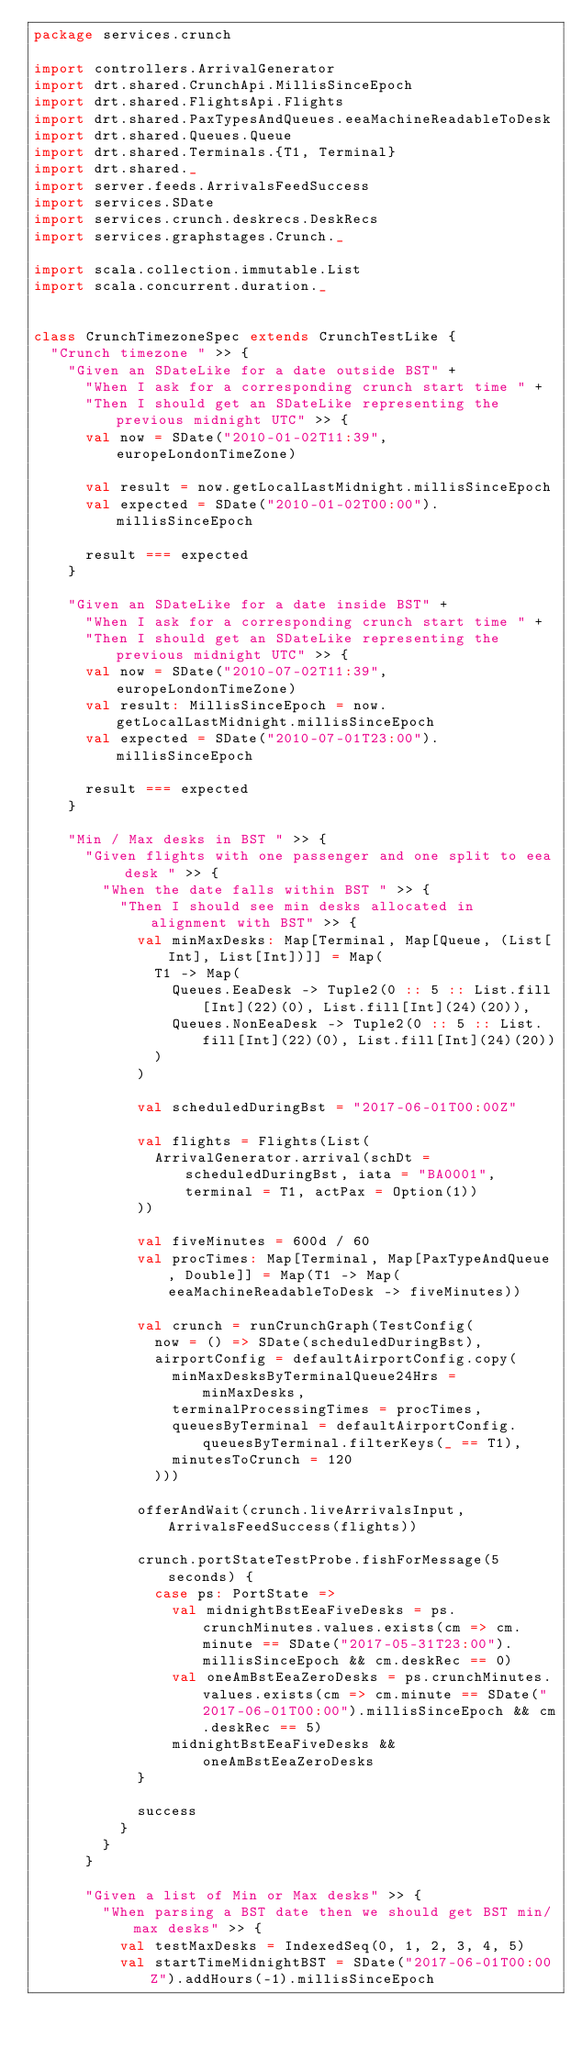Convert code to text. <code><loc_0><loc_0><loc_500><loc_500><_Scala_>package services.crunch

import controllers.ArrivalGenerator
import drt.shared.CrunchApi.MillisSinceEpoch
import drt.shared.FlightsApi.Flights
import drt.shared.PaxTypesAndQueues.eeaMachineReadableToDesk
import drt.shared.Queues.Queue
import drt.shared.Terminals.{T1, Terminal}
import drt.shared._
import server.feeds.ArrivalsFeedSuccess
import services.SDate
import services.crunch.deskrecs.DeskRecs
import services.graphstages.Crunch._

import scala.collection.immutable.List
import scala.concurrent.duration._


class CrunchTimezoneSpec extends CrunchTestLike {
  "Crunch timezone " >> {
    "Given an SDateLike for a date outside BST" +
      "When I ask for a corresponding crunch start time " +
      "Then I should get an SDateLike representing the previous midnight UTC" >> {
      val now = SDate("2010-01-02T11:39", europeLondonTimeZone)

      val result = now.getLocalLastMidnight.millisSinceEpoch
      val expected = SDate("2010-01-02T00:00").millisSinceEpoch

      result === expected
    }

    "Given an SDateLike for a date inside BST" +
      "When I ask for a corresponding crunch start time " +
      "Then I should get an SDateLike representing the previous midnight UTC" >> {
      val now = SDate("2010-07-02T11:39", europeLondonTimeZone)
      val result: MillisSinceEpoch = now.getLocalLastMidnight.millisSinceEpoch
      val expected = SDate("2010-07-01T23:00").millisSinceEpoch

      result === expected
    }

    "Min / Max desks in BST " >> {
      "Given flights with one passenger and one split to eea desk " >> {
        "When the date falls within BST " >> {
          "Then I should see min desks allocated in alignment with BST" >> {
            val minMaxDesks: Map[Terminal, Map[Queue, (List[Int], List[Int])]] = Map(
              T1 -> Map(
                Queues.EeaDesk -> Tuple2(0 :: 5 :: List.fill[Int](22)(0), List.fill[Int](24)(20)),
                Queues.NonEeaDesk -> Tuple2(0 :: 5 :: List.fill[Int](22)(0), List.fill[Int](24)(20))
              )
            )

            val scheduledDuringBst = "2017-06-01T00:00Z"

            val flights = Flights(List(
              ArrivalGenerator.arrival(schDt = scheduledDuringBst, iata = "BA0001", terminal = T1, actPax = Option(1))
            ))

            val fiveMinutes = 600d / 60
            val procTimes: Map[Terminal, Map[PaxTypeAndQueue, Double]] = Map(T1 -> Map(eeaMachineReadableToDesk -> fiveMinutes))

            val crunch = runCrunchGraph(TestConfig(
              now = () => SDate(scheduledDuringBst),
              airportConfig = defaultAirportConfig.copy(
                minMaxDesksByTerminalQueue24Hrs = minMaxDesks,
                terminalProcessingTimes = procTimes,
                queuesByTerminal = defaultAirportConfig.queuesByTerminal.filterKeys(_ == T1),
                minutesToCrunch = 120
              )))

            offerAndWait(crunch.liveArrivalsInput, ArrivalsFeedSuccess(flights))

            crunch.portStateTestProbe.fishForMessage(5 seconds) {
              case ps: PortState =>
                val midnightBstEeaFiveDesks = ps.crunchMinutes.values.exists(cm => cm.minute == SDate("2017-05-31T23:00").millisSinceEpoch && cm.deskRec == 0)
                val oneAmBstEeaZeroDesks = ps.crunchMinutes.values.exists(cm => cm.minute == SDate("2017-06-01T00:00").millisSinceEpoch && cm.deskRec == 5)
                midnightBstEeaFiveDesks && oneAmBstEeaZeroDesks
            }

            success
          }
        }
      }

      "Given a list of Min or Max desks" >> {
        "When parsing a BST date then we should get BST min/max desks" >> {
          val testMaxDesks = IndexedSeq(0, 1, 2, 3, 4, 5)
          val startTimeMidnightBST = SDate("2017-06-01T00:00Z").addHours(-1).millisSinceEpoch
</code> 